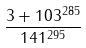Convert formula to latex. <formula><loc_0><loc_0><loc_500><loc_500>\frac { 3 + 1 0 3 ^ { 2 8 5 } } { 1 4 1 ^ { 2 9 5 } }</formula> 